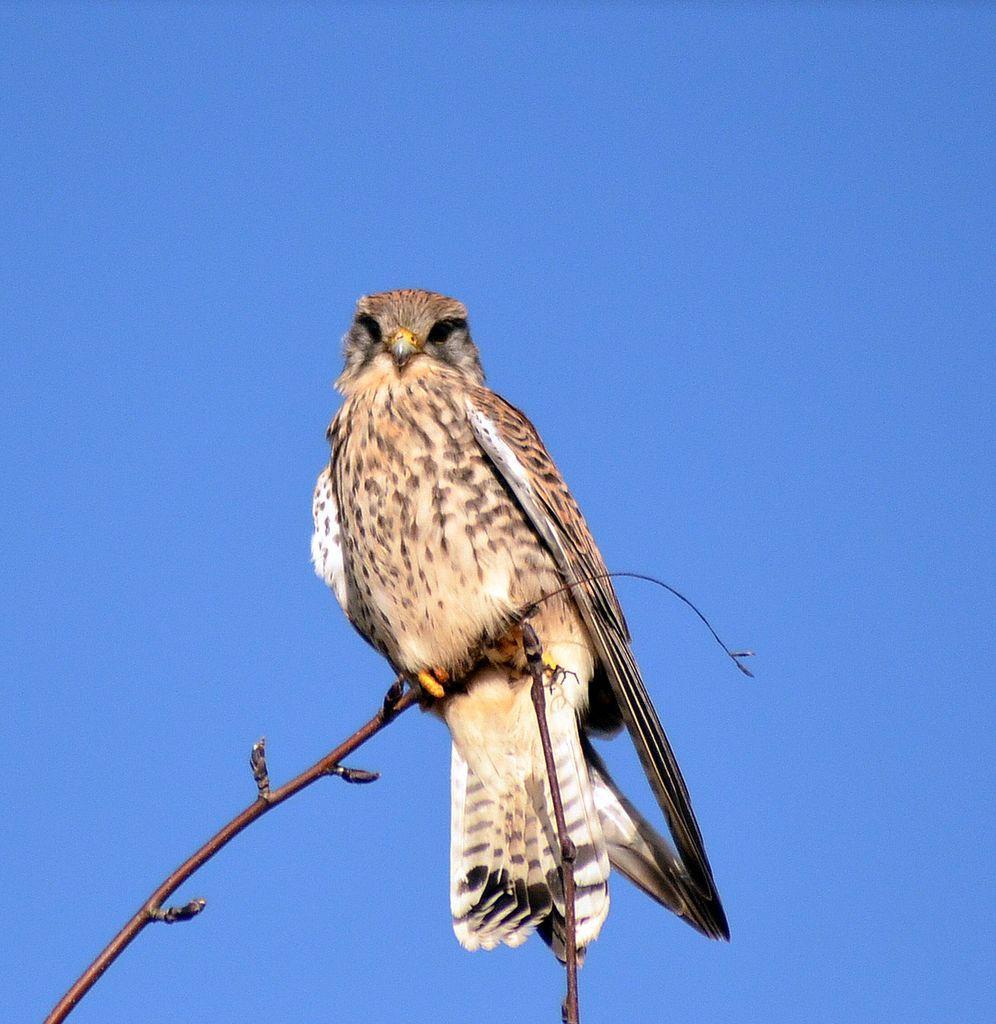How would you summarize this image in a sentence or two? In the picture we can see an eagle, which is standing on the stem of the plants and behind it, we can see a sky which is blue in color. 